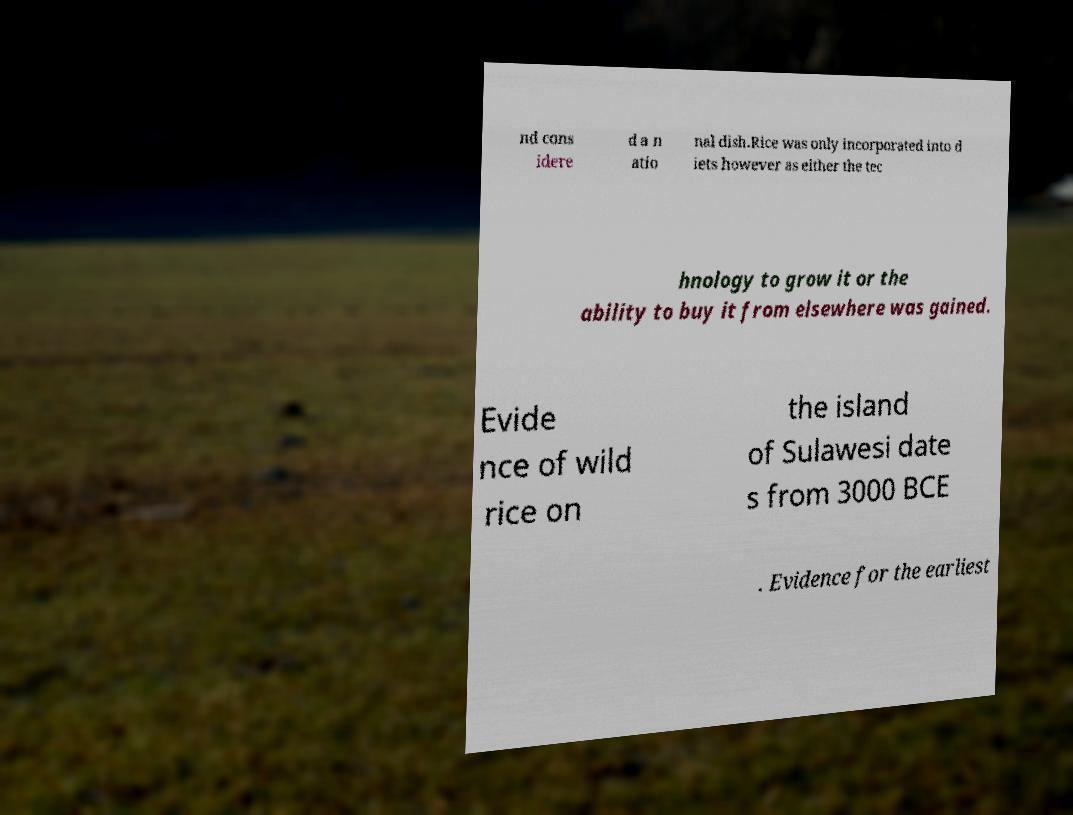Please identify and transcribe the text found in this image. nd cons idere d a n atio nal dish.Rice was only incorporated into d iets however as either the tec hnology to grow it or the ability to buy it from elsewhere was gained. Evide nce of wild rice on the island of Sulawesi date s from 3000 BCE . Evidence for the earliest 